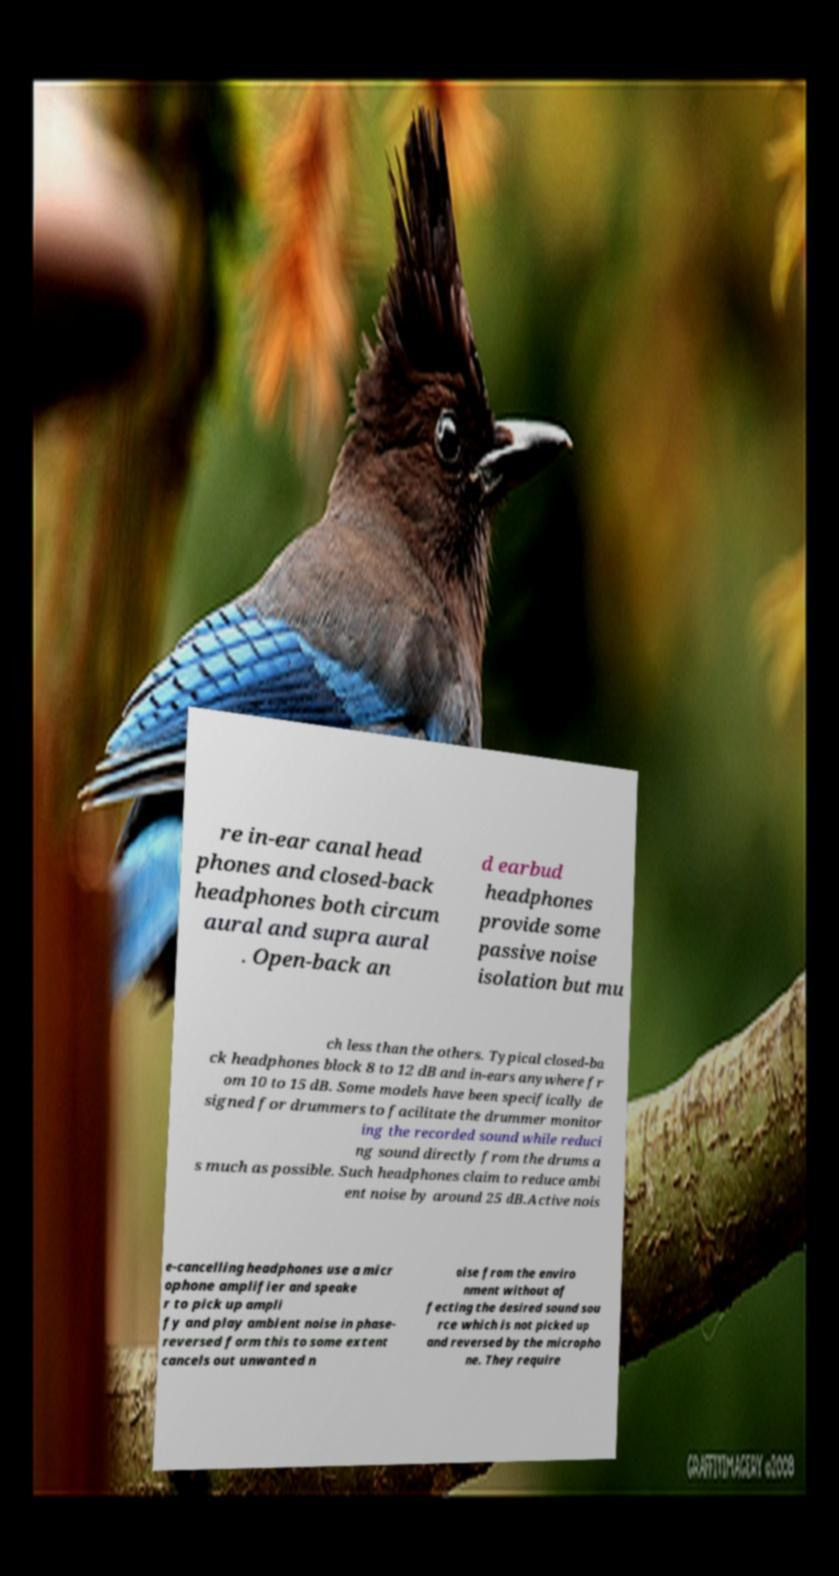Please read and relay the text visible in this image. What does it say? re in-ear canal head phones and closed-back headphones both circum aural and supra aural . Open-back an d earbud headphones provide some passive noise isolation but mu ch less than the others. Typical closed-ba ck headphones block 8 to 12 dB and in-ears anywhere fr om 10 to 15 dB. Some models have been specifically de signed for drummers to facilitate the drummer monitor ing the recorded sound while reduci ng sound directly from the drums a s much as possible. Such headphones claim to reduce ambi ent noise by around 25 dB.Active nois e-cancelling headphones use a micr ophone amplifier and speake r to pick up ampli fy and play ambient noise in phase- reversed form this to some extent cancels out unwanted n oise from the enviro nment without af fecting the desired sound sou rce which is not picked up and reversed by the micropho ne. They require 